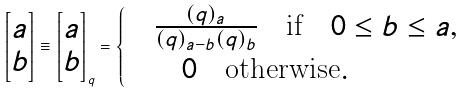<formula> <loc_0><loc_0><loc_500><loc_500>\begin{bmatrix} a \\ b \end{bmatrix} \equiv \begin{bmatrix} a \\ b \end{bmatrix} _ { q } = \begin{cases} & \frac { ( q ) _ { a } } { ( q ) _ { a - b } ( q ) _ { b } } \quad \text {if} \quad 0 \leq b \leq a , \\ & \quad 0 \quad \text {otherwise} . \end{cases}</formula> 